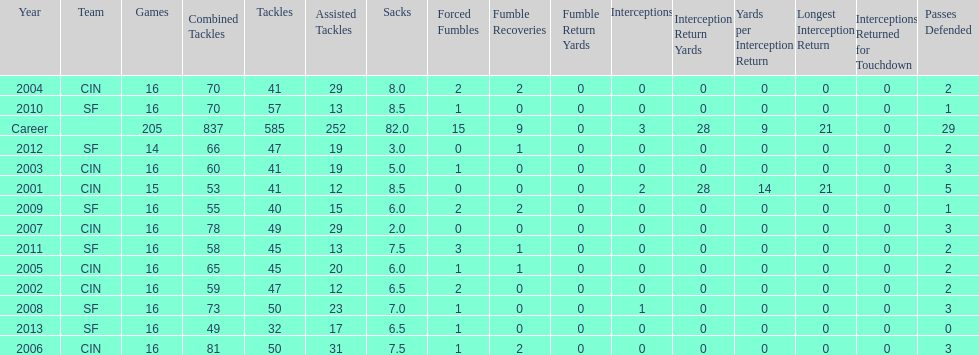What is the only season he has fewer than three sacks? 2007. 